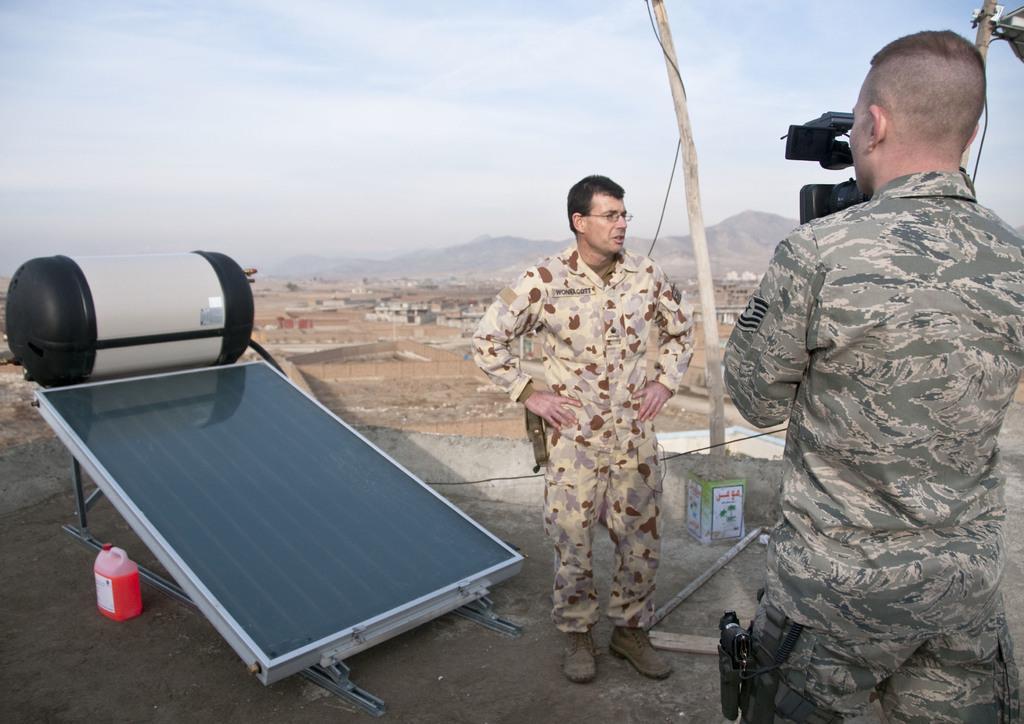In one or two sentences, can you explain what this image depicts? In the picture we can see two men are standing on the path, one man is standing and keeping the hands on his hip and he is with army uniform and to the opposite direction we can see another person standing and capturing the picture of the person who is standing and besides them we can see solar panels on the path and in the background we can see a mud surface and a hill and sky. 